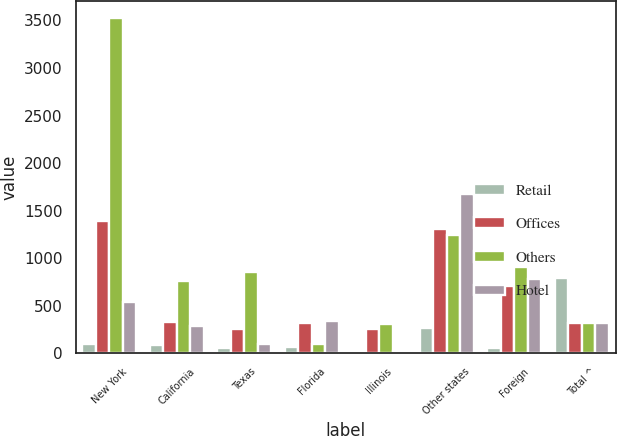Convert chart to OTSL. <chart><loc_0><loc_0><loc_500><loc_500><stacked_bar_chart><ecel><fcel>New York<fcel>California<fcel>Texas<fcel>Florida<fcel>Illinois<fcel>Other states<fcel>Foreign<fcel>Total ^<nl><fcel>Retail<fcel>96<fcel>89<fcel>58<fcel>67<fcel>19<fcel>269<fcel>59<fcel>788<nl><fcel>Offices<fcel>1391<fcel>325<fcel>255<fcel>322<fcel>258<fcel>1309<fcel>707<fcel>322<nl><fcel>Others<fcel>3527<fcel>761<fcel>857<fcel>94<fcel>307<fcel>1239<fcel>906<fcel>322<nl><fcel>Hotel<fcel>534<fcel>282<fcel>97<fcel>340<fcel>20<fcel>1670<fcel>784<fcel>322<nl></chart> 